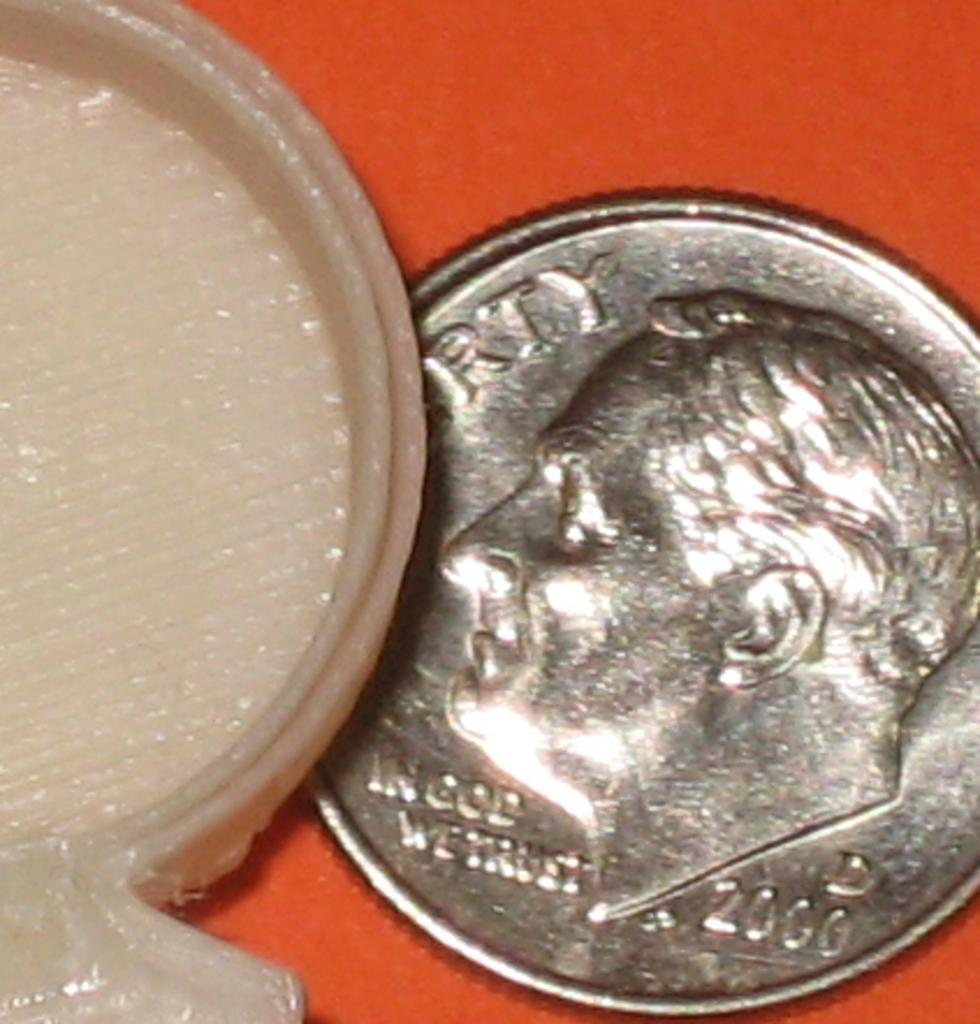<image>
Render a clear and concise summary of the photo. Macro photo of a coin from the year 2000 that says In god we trust along with an unknown white object partially covering the coin. 